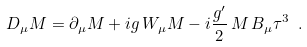Convert formula to latex. <formula><loc_0><loc_0><loc_500><loc_500>D _ { \mu } M = \partial _ { \mu } M + i g \, W _ { \mu } M - i \frac { g ^ { \prime } } { 2 } \, M \, B _ { \mu } \tau ^ { 3 } \ .</formula> 